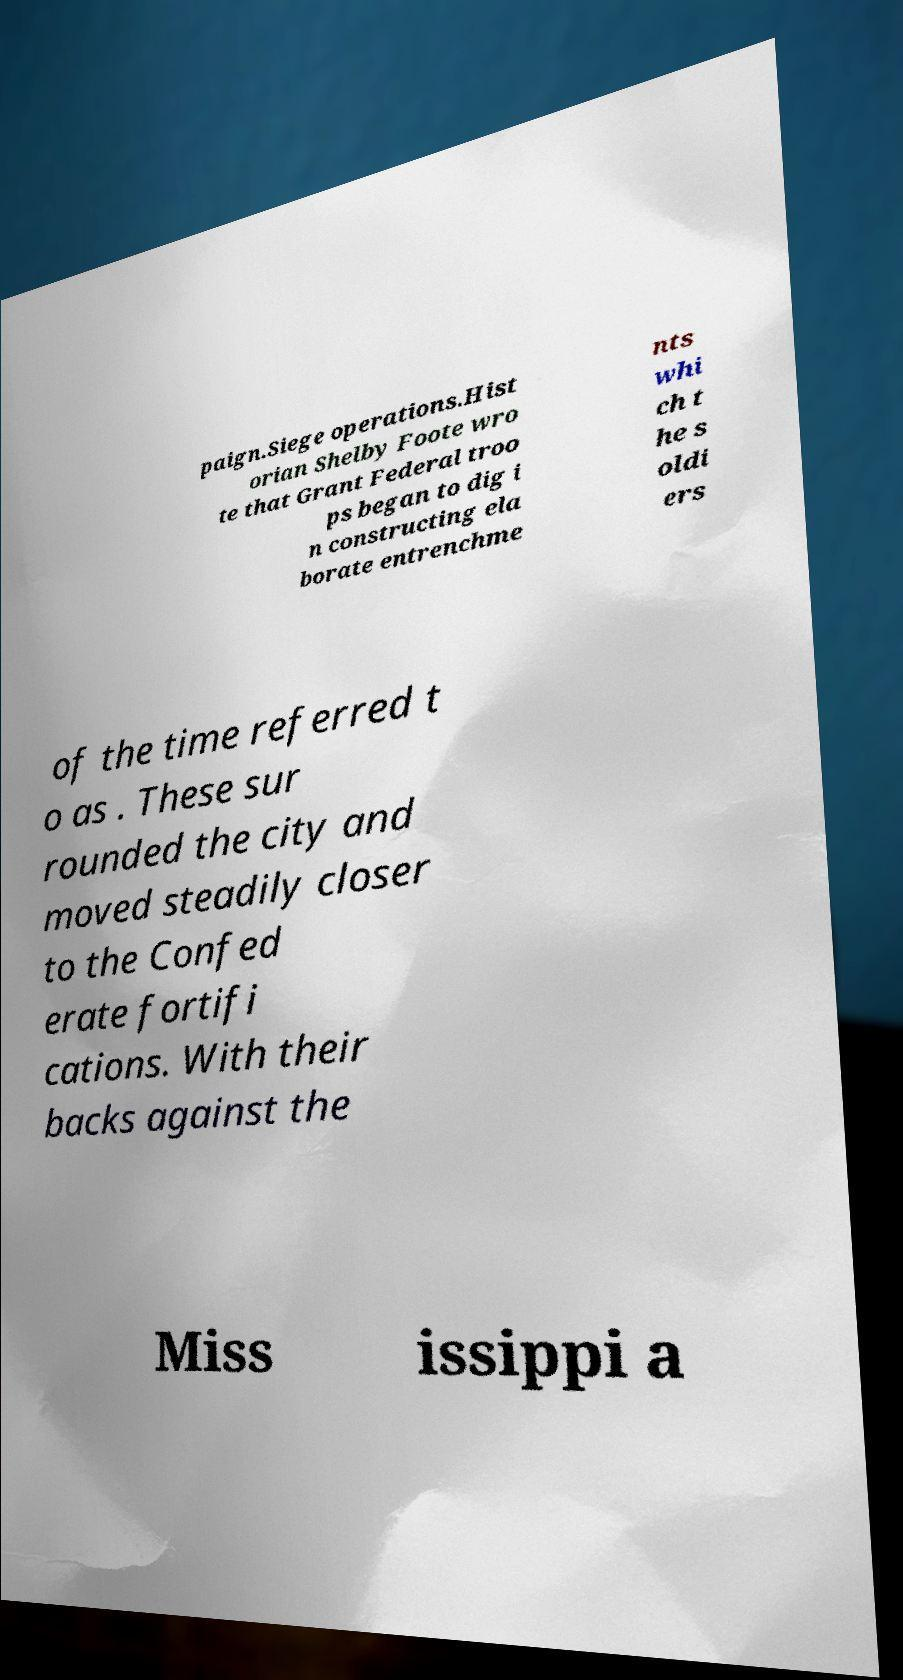Can you accurately transcribe the text from the provided image for me? paign.Siege operations.Hist orian Shelby Foote wro te that Grant Federal troo ps began to dig i n constructing ela borate entrenchme nts whi ch t he s oldi ers of the time referred t o as . These sur rounded the city and moved steadily closer to the Confed erate fortifi cations. With their backs against the Miss issippi a 